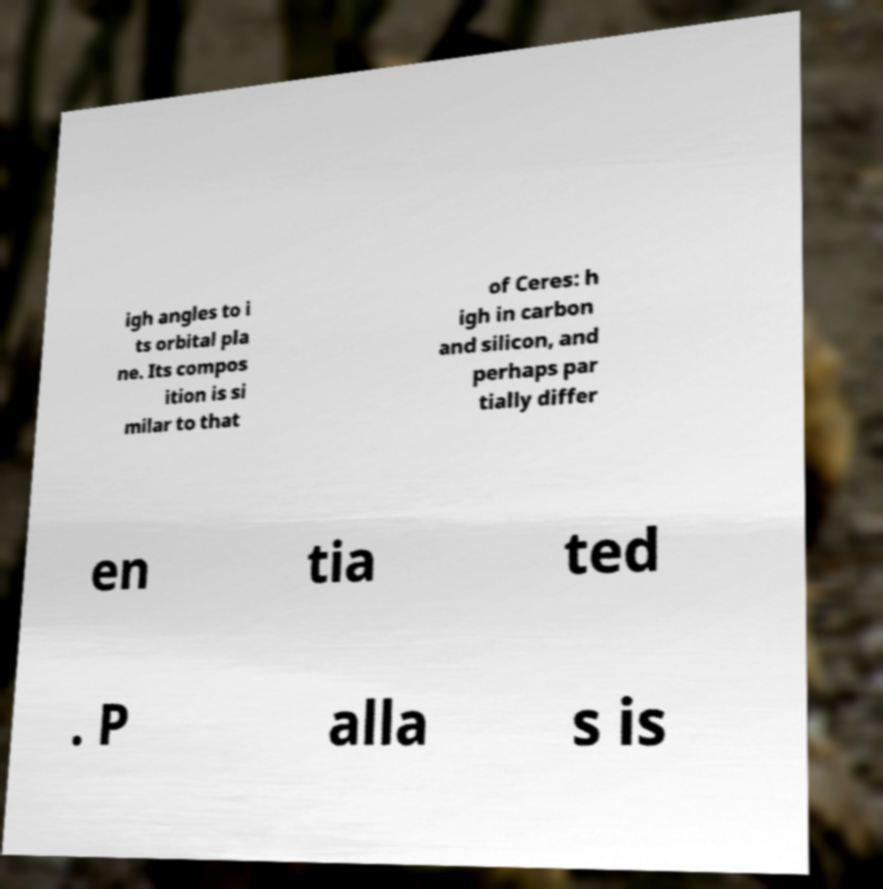Could you extract and type out the text from this image? igh angles to i ts orbital pla ne. Its compos ition is si milar to that of Ceres: h igh in carbon and silicon, and perhaps par tially differ en tia ted . P alla s is 